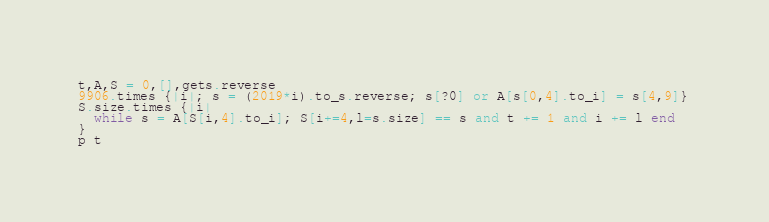<code> <loc_0><loc_0><loc_500><loc_500><_Ruby_>t,A,S = 0,[],gets.reverse
9906.times {|i|; s = (2019*i).to_s.reverse; s[?0] or A[s[0,4].to_i] = s[4,9]}
S.size.times {|i|
  while s = A[S[i,4].to_i]; S[i+=4,l=s.size] == s and t += 1 and i += l end  
}
p t</code> 